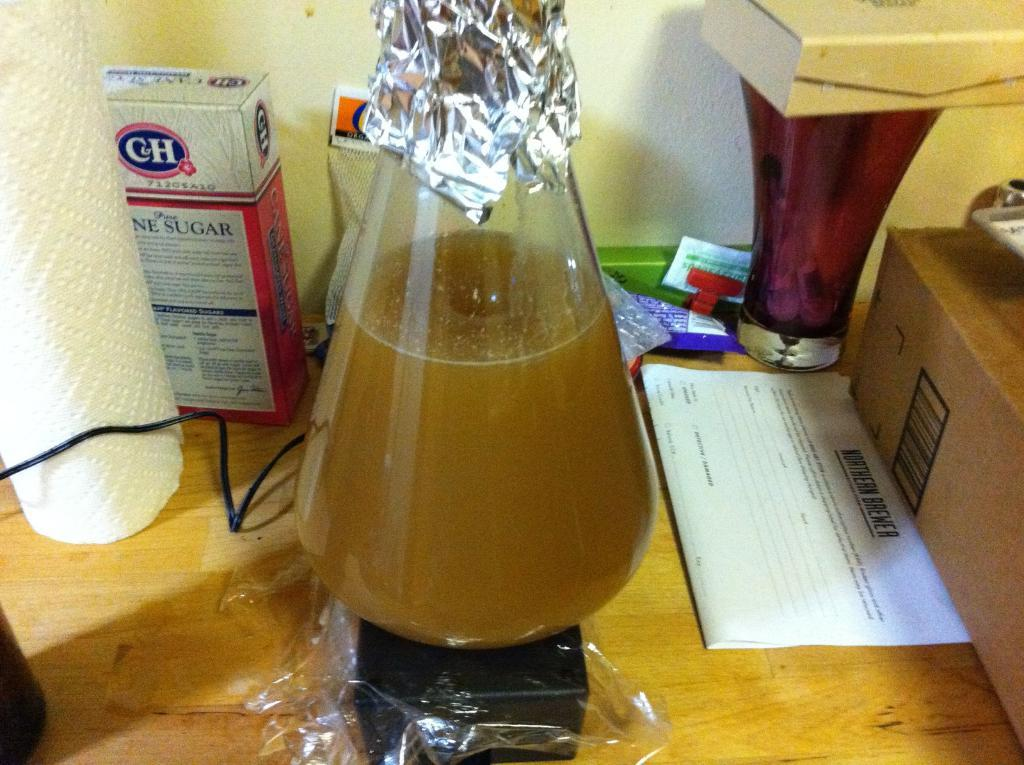<image>
Share a concise interpretation of the image provided. A box of C&H sugar sits near some paper towels and a flask of brown liquid. 